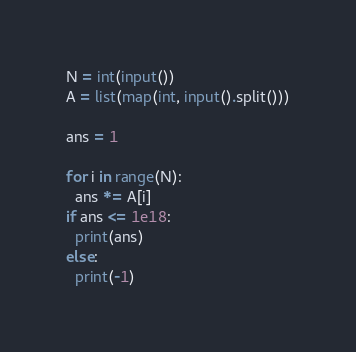<code> <loc_0><loc_0><loc_500><loc_500><_Python_>N = int(input())
A = list(map(int, input().split()))

ans = 1

for i in range(N):
  ans *= A[i]
if ans <= 1e18:
  print(ans)
else:
  print(-1)</code> 